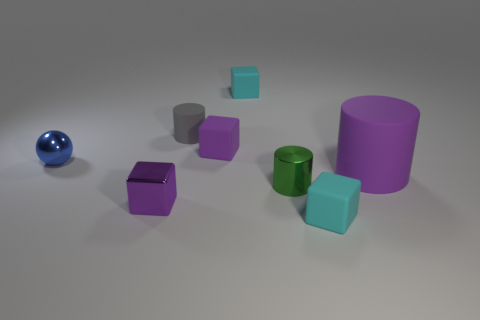Add 1 tiny purple matte things. How many objects exist? 9 Subtract all spheres. How many objects are left? 7 Subtract all gray objects. Subtract all tiny cyan things. How many objects are left? 5 Add 3 large rubber cylinders. How many large rubber cylinders are left? 4 Add 3 small brown matte spheres. How many small brown matte spheres exist? 3 Subtract 0 green spheres. How many objects are left? 8 